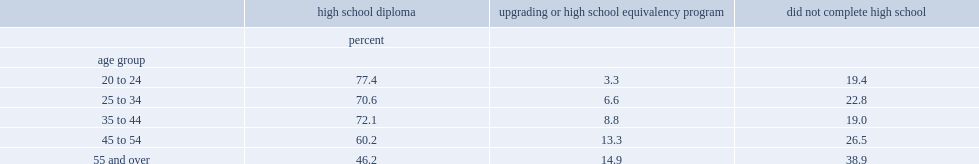How many percent of indigenous people aged 20 to 24 living off reserve had a high school diploma? 77.4. What was the percentage of those aged 55 and over with a high school diploma? 46.2. How many percent of older adults aged 55 and over did not complete high school? 38.9. How many percent of young adults aged 20 to 24 did not complete high school? 19.4. 